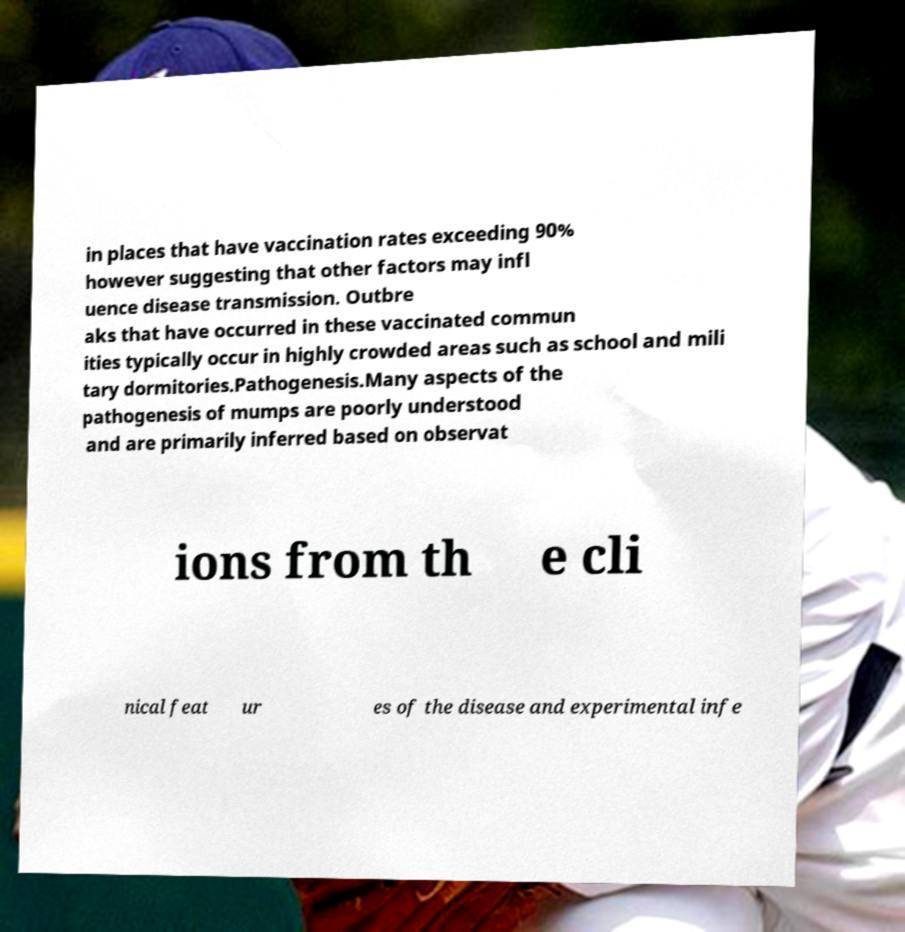Can you accurately transcribe the text from the provided image for me? in places that have vaccination rates exceeding 90% however suggesting that other factors may infl uence disease transmission. Outbre aks that have occurred in these vaccinated commun ities typically occur in highly crowded areas such as school and mili tary dormitories.Pathogenesis.Many aspects of the pathogenesis of mumps are poorly understood and are primarily inferred based on observat ions from th e cli nical feat ur es of the disease and experimental infe 